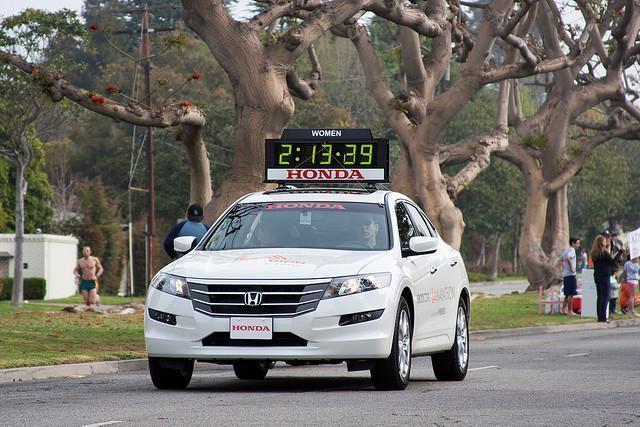How many people are on the boat not at the dock?
Give a very brief answer. 0. 